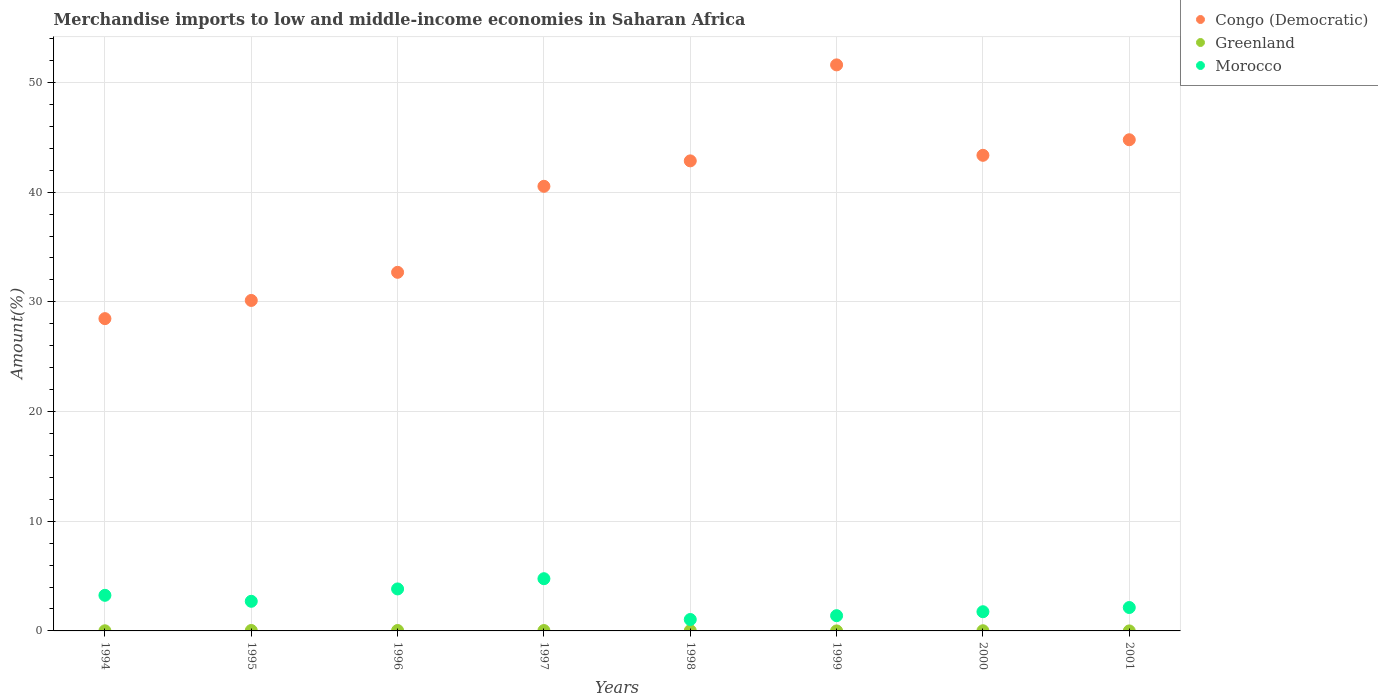How many different coloured dotlines are there?
Offer a terse response. 3. Is the number of dotlines equal to the number of legend labels?
Your answer should be compact. Yes. What is the percentage of amount earned from merchandise imports in Congo (Democratic) in 1996?
Your answer should be compact. 32.69. Across all years, what is the maximum percentage of amount earned from merchandise imports in Morocco?
Offer a very short reply. 4.76. Across all years, what is the minimum percentage of amount earned from merchandise imports in Greenland?
Your response must be concise. 0. What is the total percentage of amount earned from merchandise imports in Morocco in the graph?
Your answer should be very brief. 20.85. What is the difference between the percentage of amount earned from merchandise imports in Morocco in 1996 and that in 1997?
Your response must be concise. -0.93. What is the difference between the percentage of amount earned from merchandise imports in Congo (Democratic) in 1995 and the percentage of amount earned from merchandise imports in Morocco in 2000?
Provide a succinct answer. 28.38. What is the average percentage of amount earned from merchandise imports in Congo (Democratic) per year?
Make the answer very short. 39.3. In the year 1998, what is the difference between the percentage of amount earned from merchandise imports in Greenland and percentage of amount earned from merchandise imports in Congo (Democratic)?
Offer a terse response. -42.83. In how many years, is the percentage of amount earned from merchandise imports in Congo (Democratic) greater than 36 %?
Offer a very short reply. 5. What is the ratio of the percentage of amount earned from merchandise imports in Congo (Democratic) in 1995 to that in 2001?
Your answer should be compact. 0.67. Is the percentage of amount earned from merchandise imports in Morocco in 1998 less than that in 2001?
Provide a short and direct response. Yes. What is the difference between the highest and the second highest percentage of amount earned from merchandise imports in Congo (Democratic)?
Your answer should be compact. 6.83. What is the difference between the highest and the lowest percentage of amount earned from merchandise imports in Congo (Democratic)?
Offer a very short reply. 23.13. Is the sum of the percentage of amount earned from merchandise imports in Greenland in 1998 and 2000 greater than the maximum percentage of amount earned from merchandise imports in Morocco across all years?
Provide a short and direct response. No. Does the percentage of amount earned from merchandise imports in Morocco monotonically increase over the years?
Offer a terse response. No. What is the difference between two consecutive major ticks on the Y-axis?
Your response must be concise. 10. Does the graph contain any zero values?
Your response must be concise. No. Does the graph contain grids?
Offer a very short reply. Yes. What is the title of the graph?
Keep it short and to the point. Merchandise imports to low and middle-income economies in Saharan Africa. Does "Faeroe Islands" appear as one of the legend labels in the graph?
Offer a terse response. No. What is the label or title of the Y-axis?
Your response must be concise. Amount(%). What is the Amount(%) of Congo (Democratic) in 1994?
Make the answer very short. 28.47. What is the Amount(%) in Greenland in 1994?
Provide a short and direct response. 0.01. What is the Amount(%) in Morocco in 1994?
Provide a succinct answer. 3.25. What is the Amount(%) in Congo (Democratic) in 1995?
Keep it short and to the point. 30.13. What is the Amount(%) in Greenland in 1995?
Offer a terse response. 0.04. What is the Amount(%) in Morocco in 1995?
Your response must be concise. 2.7. What is the Amount(%) of Congo (Democratic) in 1996?
Provide a short and direct response. 32.69. What is the Amount(%) of Greenland in 1996?
Give a very brief answer. 0.04. What is the Amount(%) in Morocco in 1996?
Ensure brevity in your answer.  3.83. What is the Amount(%) of Congo (Democratic) in 1997?
Ensure brevity in your answer.  40.53. What is the Amount(%) of Greenland in 1997?
Your answer should be very brief. 0.03. What is the Amount(%) of Morocco in 1997?
Your answer should be compact. 4.76. What is the Amount(%) in Congo (Democratic) in 1998?
Your answer should be compact. 42.85. What is the Amount(%) of Greenland in 1998?
Your answer should be compact. 0.02. What is the Amount(%) in Morocco in 1998?
Provide a succinct answer. 1.04. What is the Amount(%) in Congo (Democratic) in 1999?
Provide a succinct answer. 51.6. What is the Amount(%) of Greenland in 1999?
Offer a terse response. 0. What is the Amount(%) in Morocco in 1999?
Offer a terse response. 1.39. What is the Amount(%) of Congo (Democratic) in 2000?
Make the answer very short. 43.36. What is the Amount(%) in Greenland in 2000?
Keep it short and to the point. 0.02. What is the Amount(%) of Morocco in 2000?
Your answer should be very brief. 1.75. What is the Amount(%) in Congo (Democratic) in 2001?
Ensure brevity in your answer.  44.78. What is the Amount(%) in Greenland in 2001?
Provide a short and direct response. 0. What is the Amount(%) in Morocco in 2001?
Keep it short and to the point. 2.13. Across all years, what is the maximum Amount(%) of Congo (Democratic)?
Make the answer very short. 51.6. Across all years, what is the maximum Amount(%) of Greenland?
Provide a succinct answer. 0.04. Across all years, what is the maximum Amount(%) in Morocco?
Your answer should be very brief. 4.76. Across all years, what is the minimum Amount(%) in Congo (Democratic)?
Ensure brevity in your answer.  28.47. Across all years, what is the minimum Amount(%) of Greenland?
Offer a very short reply. 0. Across all years, what is the minimum Amount(%) of Morocco?
Ensure brevity in your answer.  1.04. What is the total Amount(%) of Congo (Democratic) in the graph?
Offer a terse response. 314.4. What is the total Amount(%) of Greenland in the graph?
Keep it short and to the point. 0.17. What is the total Amount(%) of Morocco in the graph?
Provide a succinct answer. 20.85. What is the difference between the Amount(%) of Congo (Democratic) in 1994 and that in 1995?
Give a very brief answer. -1.66. What is the difference between the Amount(%) in Greenland in 1994 and that in 1995?
Offer a very short reply. -0.03. What is the difference between the Amount(%) in Morocco in 1994 and that in 1995?
Your response must be concise. 0.55. What is the difference between the Amount(%) of Congo (Democratic) in 1994 and that in 1996?
Provide a succinct answer. -4.22. What is the difference between the Amount(%) of Greenland in 1994 and that in 1996?
Provide a short and direct response. -0.03. What is the difference between the Amount(%) in Morocco in 1994 and that in 1996?
Keep it short and to the point. -0.58. What is the difference between the Amount(%) of Congo (Democratic) in 1994 and that in 1997?
Provide a succinct answer. -12.06. What is the difference between the Amount(%) of Greenland in 1994 and that in 1997?
Your answer should be very brief. -0.02. What is the difference between the Amount(%) in Morocco in 1994 and that in 1997?
Give a very brief answer. -1.51. What is the difference between the Amount(%) in Congo (Democratic) in 1994 and that in 1998?
Give a very brief answer. -14.38. What is the difference between the Amount(%) in Greenland in 1994 and that in 1998?
Your answer should be compact. -0.01. What is the difference between the Amount(%) in Morocco in 1994 and that in 1998?
Make the answer very short. 2.2. What is the difference between the Amount(%) in Congo (Democratic) in 1994 and that in 1999?
Make the answer very short. -23.13. What is the difference between the Amount(%) in Greenland in 1994 and that in 1999?
Keep it short and to the point. 0.01. What is the difference between the Amount(%) in Morocco in 1994 and that in 1999?
Give a very brief answer. 1.86. What is the difference between the Amount(%) in Congo (Democratic) in 1994 and that in 2000?
Provide a succinct answer. -14.89. What is the difference between the Amount(%) in Greenland in 1994 and that in 2000?
Offer a terse response. -0. What is the difference between the Amount(%) of Morocco in 1994 and that in 2000?
Offer a very short reply. 1.5. What is the difference between the Amount(%) of Congo (Democratic) in 1994 and that in 2001?
Give a very brief answer. -16.31. What is the difference between the Amount(%) of Greenland in 1994 and that in 2001?
Keep it short and to the point. 0.01. What is the difference between the Amount(%) of Morocco in 1994 and that in 2001?
Your answer should be compact. 1.11. What is the difference between the Amount(%) in Congo (Democratic) in 1995 and that in 1996?
Ensure brevity in your answer.  -2.56. What is the difference between the Amount(%) of Greenland in 1995 and that in 1996?
Offer a very short reply. 0. What is the difference between the Amount(%) in Morocco in 1995 and that in 1996?
Ensure brevity in your answer.  -1.13. What is the difference between the Amount(%) in Congo (Democratic) in 1995 and that in 1997?
Offer a very short reply. -10.4. What is the difference between the Amount(%) of Greenland in 1995 and that in 1997?
Your answer should be very brief. 0.01. What is the difference between the Amount(%) in Morocco in 1995 and that in 1997?
Keep it short and to the point. -2.06. What is the difference between the Amount(%) in Congo (Democratic) in 1995 and that in 1998?
Offer a very short reply. -12.72. What is the difference between the Amount(%) of Greenland in 1995 and that in 1998?
Offer a very short reply. 0.02. What is the difference between the Amount(%) in Morocco in 1995 and that in 1998?
Give a very brief answer. 1.66. What is the difference between the Amount(%) in Congo (Democratic) in 1995 and that in 1999?
Provide a succinct answer. -21.47. What is the difference between the Amount(%) in Greenland in 1995 and that in 1999?
Ensure brevity in your answer.  0.04. What is the difference between the Amount(%) of Morocco in 1995 and that in 1999?
Provide a succinct answer. 1.31. What is the difference between the Amount(%) in Congo (Democratic) in 1995 and that in 2000?
Make the answer very short. -13.23. What is the difference between the Amount(%) of Greenland in 1995 and that in 2000?
Your response must be concise. 0.02. What is the difference between the Amount(%) in Morocco in 1995 and that in 2000?
Your answer should be compact. 0.95. What is the difference between the Amount(%) in Congo (Democratic) in 1995 and that in 2001?
Provide a short and direct response. -14.65. What is the difference between the Amount(%) in Greenland in 1995 and that in 2001?
Your answer should be very brief. 0.04. What is the difference between the Amount(%) in Morocco in 1995 and that in 2001?
Your response must be concise. 0.57. What is the difference between the Amount(%) in Congo (Democratic) in 1996 and that in 1997?
Provide a succinct answer. -7.84. What is the difference between the Amount(%) in Greenland in 1996 and that in 1997?
Make the answer very short. 0.01. What is the difference between the Amount(%) of Morocco in 1996 and that in 1997?
Make the answer very short. -0.93. What is the difference between the Amount(%) in Congo (Democratic) in 1996 and that in 1998?
Keep it short and to the point. -10.16. What is the difference between the Amount(%) of Greenland in 1996 and that in 1998?
Offer a very short reply. 0.02. What is the difference between the Amount(%) in Morocco in 1996 and that in 1998?
Make the answer very short. 2.79. What is the difference between the Amount(%) of Congo (Democratic) in 1996 and that in 1999?
Keep it short and to the point. -18.91. What is the difference between the Amount(%) of Greenland in 1996 and that in 1999?
Give a very brief answer. 0.04. What is the difference between the Amount(%) of Morocco in 1996 and that in 1999?
Offer a terse response. 2.44. What is the difference between the Amount(%) in Congo (Democratic) in 1996 and that in 2000?
Offer a very short reply. -10.67. What is the difference between the Amount(%) of Greenland in 1996 and that in 2000?
Your answer should be compact. 0.02. What is the difference between the Amount(%) in Morocco in 1996 and that in 2000?
Give a very brief answer. 2.08. What is the difference between the Amount(%) of Congo (Democratic) in 1996 and that in 2001?
Offer a terse response. -12.08. What is the difference between the Amount(%) of Greenland in 1996 and that in 2001?
Make the answer very short. 0.04. What is the difference between the Amount(%) of Morocco in 1996 and that in 2001?
Provide a short and direct response. 1.69. What is the difference between the Amount(%) of Congo (Democratic) in 1997 and that in 1998?
Your answer should be very brief. -2.32. What is the difference between the Amount(%) of Greenland in 1997 and that in 1998?
Provide a short and direct response. 0.01. What is the difference between the Amount(%) in Morocco in 1997 and that in 1998?
Provide a short and direct response. 3.72. What is the difference between the Amount(%) in Congo (Democratic) in 1997 and that in 1999?
Ensure brevity in your answer.  -11.07. What is the difference between the Amount(%) in Greenland in 1997 and that in 1999?
Give a very brief answer. 0.03. What is the difference between the Amount(%) in Morocco in 1997 and that in 1999?
Provide a succinct answer. 3.37. What is the difference between the Amount(%) of Congo (Democratic) in 1997 and that in 2000?
Give a very brief answer. -2.83. What is the difference between the Amount(%) in Greenland in 1997 and that in 2000?
Ensure brevity in your answer.  0.02. What is the difference between the Amount(%) in Morocco in 1997 and that in 2000?
Offer a very short reply. 3.01. What is the difference between the Amount(%) of Congo (Democratic) in 1997 and that in 2001?
Provide a short and direct response. -4.24. What is the difference between the Amount(%) of Greenland in 1997 and that in 2001?
Give a very brief answer. 0.03. What is the difference between the Amount(%) of Morocco in 1997 and that in 2001?
Offer a very short reply. 2.63. What is the difference between the Amount(%) in Congo (Democratic) in 1998 and that in 1999?
Provide a succinct answer. -8.75. What is the difference between the Amount(%) of Greenland in 1998 and that in 1999?
Your answer should be very brief. 0.02. What is the difference between the Amount(%) of Morocco in 1998 and that in 1999?
Provide a short and direct response. -0.35. What is the difference between the Amount(%) in Congo (Democratic) in 1998 and that in 2000?
Your answer should be very brief. -0.51. What is the difference between the Amount(%) of Greenland in 1998 and that in 2000?
Make the answer very short. 0.01. What is the difference between the Amount(%) of Morocco in 1998 and that in 2000?
Provide a succinct answer. -0.71. What is the difference between the Amount(%) of Congo (Democratic) in 1998 and that in 2001?
Give a very brief answer. -1.93. What is the difference between the Amount(%) of Greenland in 1998 and that in 2001?
Provide a succinct answer. 0.02. What is the difference between the Amount(%) in Morocco in 1998 and that in 2001?
Keep it short and to the point. -1.09. What is the difference between the Amount(%) of Congo (Democratic) in 1999 and that in 2000?
Make the answer very short. 8.24. What is the difference between the Amount(%) of Greenland in 1999 and that in 2000?
Make the answer very short. -0.02. What is the difference between the Amount(%) in Morocco in 1999 and that in 2000?
Provide a short and direct response. -0.36. What is the difference between the Amount(%) in Congo (Democratic) in 1999 and that in 2001?
Provide a succinct answer. 6.83. What is the difference between the Amount(%) in Greenland in 1999 and that in 2001?
Provide a short and direct response. 0. What is the difference between the Amount(%) in Morocco in 1999 and that in 2001?
Offer a very short reply. -0.74. What is the difference between the Amount(%) in Congo (Democratic) in 2000 and that in 2001?
Provide a succinct answer. -1.42. What is the difference between the Amount(%) in Greenland in 2000 and that in 2001?
Provide a short and direct response. 0.02. What is the difference between the Amount(%) in Morocco in 2000 and that in 2001?
Offer a terse response. -0.38. What is the difference between the Amount(%) in Congo (Democratic) in 1994 and the Amount(%) in Greenland in 1995?
Give a very brief answer. 28.43. What is the difference between the Amount(%) in Congo (Democratic) in 1994 and the Amount(%) in Morocco in 1995?
Make the answer very short. 25.77. What is the difference between the Amount(%) of Greenland in 1994 and the Amount(%) of Morocco in 1995?
Your answer should be very brief. -2.69. What is the difference between the Amount(%) of Congo (Democratic) in 1994 and the Amount(%) of Greenland in 1996?
Offer a terse response. 28.43. What is the difference between the Amount(%) of Congo (Democratic) in 1994 and the Amount(%) of Morocco in 1996?
Keep it short and to the point. 24.64. What is the difference between the Amount(%) of Greenland in 1994 and the Amount(%) of Morocco in 1996?
Provide a succinct answer. -3.82. What is the difference between the Amount(%) in Congo (Democratic) in 1994 and the Amount(%) in Greenland in 1997?
Ensure brevity in your answer.  28.43. What is the difference between the Amount(%) in Congo (Democratic) in 1994 and the Amount(%) in Morocco in 1997?
Your answer should be compact. 23.71. What is the difference between the Amount(%) of Greenland in 1994 and the Amount(%) of Morocco in 1997?
Provide a short and direct response. -4.75. What is the difference between the Amount(%) of Congo (Democratic) in 1994 and the Amount(%) of Greenland in 1998?
Your answer should be compact. 28.44. What is the difference between the Amount(%) of Congo (Democratic) in 1994 and the Amount(%) of Morocco in 1998?
Your response must be concise. 27.43. What is the difference between the Amount(%) in Greenland in 1994 and the Amount(%) in Morocco in 1998?
Provide a short and direct response. -1.03. What is the difference between the Amount(%) of Congo (Democratic) in 1994 and the Amount(%) of Greenland in 1999?
Make the answer very short. 28.47. What is the difference between the Amount(%) in Congo (Democratic) in 1994 and the Amount(%) in Morocco in 1999?
Make the answer very short. 27.08. What is the difference between the Amount(%) of Greenland in 1994 and the Amount(%) of Morocco in 1999?
Make the answer very short. -1.38. What is the difference between the Amount(%) in Congo (Democratic) in 1994 and the Amount(%) in Greenland in 2000?
Your response must be concise. 28.45. What is the difference between the Amount(%) in Congo (Democratic) in 1994 and the Amount(%) in Morocco in 2000?
Offer a terse response. 26.72. What is the difference between the Amount(%) in Greenland in 1994 and the Amount(%) in Morocco in 2000?
Provide a short and direct response. -1.74. What is the difference between the Amount(%) of Congo (Democratic) in 1994 and the Amount(%) of Greenland in 2001?
Your answer should be compact. 28.47. What is the difference between the Amount(%) of Congo (Democratic) in 1994 and the Amount(%) of Morocco in 2001?
Your answer should be very brief. 26.33. What is the difference between the Amount(%) of Greenland in 1994 and the Amount(%) of Morocco in 2001?
Keep it short and to the point. -2.12. What is the difference between the Amount(%) in Congo (Democratic) in 1995 and the Amount(%) in Greenland in 1996?
Provide a short and direct response. 30.09. What is the difference between the Amount(%) of Congo (Democratic) in 1995 and the Amount(%) of Morocco in 1996?
Your response must be concise. 26.3. What is the difference between the Amount(%) of Greenland in 1995 and the Amount(%) of Morocco in 1996?
Offer a very short reply. -3.79. What is the difference between the Amount(%) of Congo (Democratic) in 1995 and the Amount(%) of Greenland in 1997?
Offer a terse response. 30.09. What is the difference between the Amount(%) of Congo (Democratic) in 1995 and the Amount(%) of Morocco in 1997?
Your answer should be very brief. 25.37. What is the difference between the Amount(%) of Greenland in 1995 and the Amount(%) of Morocco in 1997?
Give a very brief answer. -4.72. What is the difference between the Amount(%) in Congo (Democratic) in 1995 and the Amount(%) in Greenland in 1998?
Make the answer very short. 30.1. What is the difference between the Amount(%) of Congo (Democratic) in 1995 and the Amount(%) of Morocco in 1998?
Offer a very short reply. 29.09. What is the difference between the Amount(%) of Greenland in 1995 and the Amount(%) of Morocco in 1998?
Offer a very short reply. -1. What is the difference between the Amount(%) of Congo (Democratic) in 1995 and the Amount(%) of Greenland in 1999?
Provide a succinct answer. 30.13. What is the difference between the Amount(%) of Congo (Democratic) in 1995 and the Amount(%) of Morocco in 1999?
Your answer should be very brief. 28.74. What is the difference between the Amount(%) in Greenland in 1995 and the Amount(%) in Morocco in 1999?
Provide a short and direct response. -1.35. What is the difference between the Amount(%) in Congo (Democratic) in 1995 and the Amount(%) in Greenland in 2000?
Provide a short and direct response. 30.11. What is the difference between the Amount(%) of Congo (Democratic) in 1995 and the Amount(%) of Morocco in 2000?
Make the answer very short. 28.38. What is the difference between the Amount(%) in Greenland in 1995 and the Amount(%) in Morocco in 2000?
Give a very brief answer. -1.71. What is the difference between the Amount(%) in Congo (Democratic) in 1995 and the Amount(%) in Greenland in 2001?
Provide a succinct answer. 30.13. What is the difference between the Amount(%) of Congo (Democratic) in 1995 and the Amount(%) of Morocco in 2001?
Provide a succinct answer. 27.99. What is the difference between the Amount(%) in Greenland in 1995 and the Amount(%) in Morocco in 2001?
Your answer should be very brief. -2.09. What is the difference between the Amount(%) of Congo (Democratic) in 1996 and the Amount(%) of Greenland in 1997?
Provide a short and direct response. 32.66. What is the difference between the Amount(%) in Congo (Democratic) in 1996 and the Amount(%) in Morocco in 1997?
Provide a short and direct response. 27.93. What is the difference between the Amount(%) of Greenland in 1996 and the Amount(%) of Morocco in 1997?
Keep it short and to the point. -4.72. What is the difference between the Amount(%) of Congo (Democratic) in 1996 and the Amount(%) of Greenland in 1998?
Offer a very short reply. 32.67. What is the difference between the Amount(%) in Congo (Democratic) in 1996 and the Amount(%) in Morocco in 1998?
Offer a very short reply. 31.65. What is the difference between the Amount(%) in Greenland in 1996 and the Amount(%) in Morocco in 1998?
Provide a short and direct response. -1. What is the difference between the Amount(%) of Congo (Democratic) in 1996 and the Amount(%) of Greenland in 1999?
Your response must be concise. 32.69. What is the difference between the Amount(%) in Congo (Democratic) in 1996 and the Amount(%) in Morocco in 1999?
Keep it short and to the point. 31.3. What is the difference between the Amount(%) of Greenland in 1996 and the Amount(%) of Morocco in 1999?
Provide a short and direct response. -1.35. What is the difference between the Amount(%) in Congo (Democratic) in 1996 and the Amount(%) in Greenland in 2000?
Your answer should be compact. 32.67. What is the difference between the Amount(%) of Congo (Democratic) in 1996 and the Amount(%) of Morocco in 2000?
Provide a succinct answer. 30.94. What is the difference between the Amount(%) in Greenland in 1996 and the Amount(%) in Morocco in 2000?
Give a very brief answer. -1.71. What is the difference between the Amount(%) in Congo (Democratic) in 1996 and the Amount(%) in Greenland in 2001?
Your response must be concise. 32.69. What is the difference between the Amount(%) of Congo (Democratic) in 1996 and the Amount(%) of Morocco in 2001?
Your answer should be very brief. 30.56. What is the difference between the Amount(%) in Greenland in 1996 and the Amount(%) in Morocco in 2001?
Ensure brevity in your answer.  -2.09. What is the difference between the Amount(%) in Congo (Democratic) in 1997 and the Amount(%) in Greenland in 1998?
Provide a succinct answer. 40.51. What is the difference between the Amount(%) of Congo (Democratic) in 1997 and the Amount(%) of Morocco in 1998?
Your answer should be very brief. 39.49. What is the difference between the Amount(%) of Greenland in 1997 and the Amount(%) of Morocco in 1998?
Ensure brevity in your answer.  -1.01. What is the difference between the Amount(%) in Congo (Democratic) in 1997 and the Amount(%) in Greenland in 1999?
Provide a succinct answer. 40.53. What is the difference between the Amount(%) in Congo (Democratic) in 1997 and the Amount(%) in Morocco in 1999?
Keep it short and to the point. 39.14. What is the difference between the Amount(%) in Greenland in 1997 and the Amount(%) in Morocco in 1999?
Provide a succinct answer. -1.36. What is the difference between the Amount(%) of Congo (Democratic) in 1997 and the Amount(%) of Greenland in 2000?
Offer a terse response. 40.51. What is the difference between the Amount(%) in Congo (Democratic) in 1997 and the Amount(%) in Morocco in 2000?
Offer a terse response. 38.78. What is the difference between the Amount(%) of Greenland in 1997 and the Amount(%) of Morocco in 2000?
Make the answer very short. -1.72. What is the difference between the Amount(%) in Congo (Democratic) in 1997 and the Amount(%) in Greenland in 2001?
Make the answer very short. 40.53. What is the difference between the Amount(%) in Congo (Democratic) in 1997 and the Amount(%) in Morocco in 2001?
Provide a succinct answer. 38.4. What is the difference between the Amount(%) of Greenland in 1997 and the Amount(%) of Morocco in 2001?
Provide a short and direct response. -2.1. What is the difference between the Amount(%) of Congo (Democratic) in 1998 and the Amount(%) of Greenland in 1999?
Your answer should be compact. 42.85. What is the difference between the Amount(%) of Congo (Democratic) in 1998 and the Amount(%) of Morocco in 1999?
Ensure brevity in your answer.  41.46. What is the difference between the Amount(%) in Greenland in 1998 and the Amount(%) in Morocco in 1999?
Ensure brevity in your answer.  -1.37. What is the difference between the Amount(%) in Congo (Democratic) in 1998 and the Amount(%) in Greenland in 2000?
Provide a succinct answer. 42.83. What is the difference between the Amount(%) in Congo (Democratic) in 1998 and the Amount(%) in Morocco in 2000?
Offer a terse response. 41.1. What is the difference between the Amount(%) in Greenland in 1998 and the Amount(%) in Morocco in 2000?
Provide a short and direct response. -1.73. What is the difference between the Amount(%) of Congo (Democratic) in 1998 and the Amount(%) of Greenland in 2001?
Ensure brevity in your answer.  42.85. What is the difference between the Amount(%) in Congo (Democratic) in 1998 and the Amount(%) in Morocco in 2001?
Provide a short and direct response. 40.72. What is the difference between the Amount(%) in Greenland in 1998 and the Amount(%) in Morocco in 2001?
Make the answer very short. -2.11. What is the difference between the Amount(%) of Congo (Democratic) in 1999 and the Amount(%) of Greenland in 2000?
Give a very brief answer. 51.58. What is the difference between the Amount(%) of Congo (Democratic) in 1999 and the Amount(%) of Morocco in 2000?
Provide a succinct answer. 49.85. What is the difference between the Amount(%) of Greenland in 1999 and the Amount(%) of Morocco in 2000?
Keep it short and to the point. -1.75. What is the difference between the Amount(%) of Congo (Democratic) in 1999 and the Amount(%) of Greenland in 2001?
Provide a short and direct response. 51.6. What is the difference between the Amount(%) of Congo (Democratic) in 1999 and the Amount(%) of Morocco in 2001?
Give a very brief answer. 49.47. What is the difference between the Amount(%) of Greenland in 1999 and the Amount(%) of Morocco in 2001?
Give a very brief answer. -2.13. What is the difference between the Amount(%) in Congo (Democratic) in 2000 and the Amount(%) in Greenland in 2001?
Ensure brevity in your answer.  43.36. What is the difference between the Amount(%) of Congo (Democratic) in 2000 and the Amount(%) of Morocco in 2001?
Your response must be concise. 41.22. What is the difference between the Amount(%) of Greenland in 2000 and the Amount(%) of Morocco in 2001?
Your answer should be compact. -2.12. What is the average Amount(%) of Congo (Democratic) per year?
Ensure brevity in your answer.  39.3. What is the average Amount(%) of Greenland per year?
Provide a short and direct response. 0.02. What is the average Amount(%) of Morocco per year?
Provide a short and direct response. 2.61. In the year 1994, what is the difference between the Amount(%) in Congo (Democratic) and Amount(%) in Greenland?
Provide a short and direct response. 28.46. In the year 1994, what is the difference between the Amount(%) of Congo (Democratic) and Amount(%) of Morocco?
Your answer should be compact. 25.22. In the year 1994, what is the difference between the Amount(%) of Greenland and Amount(%) of Morocco?
Your response must be concise. -3.23. In the year 1995, what is the difference between the Amount(%) of Congo (Democratic) and Amount(%) of Greenland?
Make the answer very short. 30.09. In the year 1995, what is the difference between the Amount(%) in Congo (Democratic) and Amount(%) in Morocco?
Your answer should be compact. 27.43. In the year 1995, what is the difference between the Amount(%) of Greenland and Amount(%) of Morocco?
Make the answer very short. -2.66. In the year 1996, what is the difference between the Amount(%) of Congo (Democratic) and Amount(%) of Greenland?
Your answer should be compact. 32.65. In the year 1996, what is the difference between the Amount(%) in Congo (Democratic) and Amount(%) in Morocco?
Keep it short and to the point. 28.86. In the year 1996, what is the difference between the Amount(%) of Greenland and Amount(%) of Morocco?
Give a very brief answer. -3.79. In the year 1997, what is the difference between the Amount(%) in Congo (Democratic) and Amount(%) in Greenland?
Offer a very short reply. 40.5. In the year 1997, what is the difference between the Amount(%) of Congo (Democratic) and Amount(%) of Morocco?
Offer a terse response. 35.77. In the year 1997, what is the difference between the Amount(%) of Greenland and Amount(%) of Morocco?
Give a very brief answer. -4.73. In the year 1998, what is the difference between the Amount(%) in Congo (Democratic) and Amount(%) in Greenland?
Provide a short and direct response. 42.83. In the year 1998, what is the difference between the Amount(%) in Congo (Democratic) and Amount(%) in Morocco?
Your response must be concise. 41.81. In the year 1998, what is the difference between the Amount(%) in Greenland and Amount(%) in Morocco?
Offer a terse response. -1.02. In the year 1999, what is the difference between the Amount(%) in Congo (Democratic) and Amount(%) in Greenland?
Offer a terse response. 51.6. In the year 1999, what is the difference between the Amount(%) of Congo (Democratic) and Amount(%) of Morocco?
Your answer should be very brief. 50.21. In the year 1999, what is the difference between the Amount(%) in Greenland and Amount(%) in Morocco?
Provide a succinct answer. -1.39. In the year 2000, what is the difference between the Amount(%) of Congo (Democratic) and Amount(%) of Greenland?
Keep it short and to the point. 43.34. In the year 2000, what is the difference between the Amount(%) in Congo (Democratic) and Amount(%) in Morocco?
Ensure brevity in your answer.  41.61. In the year 2000, what is the difference between the Amount(%) of Greenland and Amount(%) of Morocco?
Keep it short and to the point. -1.73. In the year 2001, what is the difference between the Amount(%) in Congo (Democratic) and Amount(%) in Greenland?
Your answer should be very brief. 44.77. In the year 2001, what is the difference between the Amount(%) of Congo (Democratic) and Amount(%) of Morocco?
Offer a very short reply. 42.64. In the year 2001, what is the difference between the Amount(%) of Greenland and Amount(%) of Morocco?
Your answer should be compact. -2.13. What is the ratio of the Amount(%) in Congo (Democratic) in 1994 to that in 1995?
Give a very brief answer. 0.94. What is the ratio of the Amount(%) of Greenland in 1994 to that in 1995?
Your response must be concise. 0.31. What is the ratio of the Amount(%) of Morocco in 1994 to that in 1995?
Ensure brevity in your answer.  1.2. What is the ratio of the Amount(%) in Congo (Democratic) in 1994 to that in 1996?
Your answer should be very brief. 0.87. What is the ratio of the Amount(%) of Greenland in 1994 to that in 1996?
Provide a short and direct response. 0.31. What is the ratio of the Amount(%) of Morocco in 1994 to that in 1996?
Provide a short and direct response. 0.85. What is the ratio of the Amount(%) of Congo (Democratic) in 1994 to that in 1997?
Your answer should be compact. 0.7. What is the ratio of the Amount(%) in Greenland in 1994 to that in 1997?
Provide a succinct answer. 0.36. What is the ratio of the Amount(%) of Morocco in 1994 to that in 1997?
Your answer should be very brief. 0.68. What is the ratio of the Amount(%) in Congo (Democratic) in 1994 to that in 1998?
Your response must be concise. 0.66. What is the ratio of the Amount(%) of Greenland in 1994 to that in 1998?
Keep it short and to the point. 0.52. What is the ratio of the Amount(%) of Morocco in 1994 to that in 1998?
Provide a short and direct response. 3.12. What is the ratio of the Amount(%) in Congo (Democratic) in 1994 to that in 1999?
Your answer should be compact. 0.55. What is the ratio of the Amount(%) in Greenland in 1994 to that in 1999?
Your answer should be very brief. 9.49. What is the ratio of the Amount(%) of Morocco in 1994 to that in 1999?
Your answer should be very brief. 2.34. What is the ratio of the Amount(%) in Congo (Democratic) in 1994 to that in 2000?
Make the answer very short. 0.66. What is the ratio of the Amount(%) in Greenland in 1994 to that in 2000?
Offer a very short reply. 0.74. What is the ratio of the Amount(%) of Morocco in 1994 to that in 2000?
Your response must be concise. 1.85. What is the ratio of the Amount(%) in Congo (Democratic) in 1994 to that in 2001?
Ensure brevity in your answer.  0.64. What is the ratio of the Amount(%) in Greenland in 1994 to that in 2001?
Offer a very short reply. 21.29. What is the ratio of the Amount(%) in Morocco in 1994 to that in 2001?
Provide a succinct answer. 1.52. What is the ratio of the Amount(%) in Congo (Democratic) in 1995 to that in 1996?
Your response must be concise. 0.92. What is the ratio of the Amount(%) in Greenland in 1995 to that in 1996?
Give a very brief answer. 1.02. What is the ratio of the Amount(%) of Morocco in 1995 to that in 1996?
Keep it short and to the point. 0.71. What is the ratio of the Amount(%) of Congo (Democratic) in 1995 to that in 1997?
Your response must be concise. 0.74. What is the ratio of the Amount(%) of Greenland in 1995 to that in 1997?
Your answer should be very brief. 1.17. What is the ratio of the Amount(%) of Morocco in 1995 to that in 1997?
Your answer should be very brief. 0.57. What is the ratio of the Amount(%) in Congo (Democratic) in 1995 to that in 1998?
Keep it short and to the point. 0.7. What is the ratio of the Amount(%) in Greenland in 1995 to that in 1998?
Give a very brief answer. 1.68. What is the ratio of the Amount(%) in Morocco in 1995 to that in 1998?
Your answer should be very brief. 2.59. What is the ratio of the Amount(%) in Congo (Democratic) in 1995 to that in 1999?
Provide a succinct answer. 0.58. What is the ratio of the Amount(%) in Greenland in 1995 to that in 1999?
Provide a short and direct response. 30.94. What is the ratio of the Amount(%) in Morocco in 1995 to that in 1999?
Make the answer very short. 1.94. What is the ratio of the Amount(%) of Congo (Democratic) in 1995 to that in 2000?
Provide a succinct answer. 0.69. What is the ratio of the Amount(%) in Greenland in 1995 to that in 2000?
Your answer should be very brief. 2.42. What is the ratio of the Amount(%) of Morocco in 1995 to that in 2000?
Your response must be concise. 1.54. What is the ratio of the Amount(%) in Congo (Democratic) in 1995 to that in 2001?
Keep it short and to the point. 0.67. What is the ratio of the Amount(%) of Greenland in 1995 to that in 2001?
Offer a terse response. 69.41. What is the ratio of the Amount(%) of Morocco in 1995 to that in 2001?
Provide a short and direct response. 1.27. What is the ratio of the Amount(%) in Congo (Democratic) in 1996 to that in 1997?
Make the answer very short. 0.81. What is the ratio of the Amount(%) in Greenland in 1996 to that in 1997?
Make the answer very short. 1.15. What is the ratio of the Amount(%) of Morocco in 1996 to that in 1997?
Your response must be concise. 0.8. What is the ratio of the Amount(%) in Congo (Democratic) in 1996 to that in 1998?
Make the answer very short. 0.76. What is the ratio of the Amount(%) in Greenland in 1996 to that in 1998?
Give a very brief answer. 1.66. What is the ratio of the Amount(%) of Morocco in 1996 to that in 1998?
Your answer should be compact. 3.68. What is the ratio of the Amount(%) in Congo (Democratic) in 1996 to that in 1999?
Ensure brevity in your answer.  0.63. What is the ratio of the Amount(%) of Greenland in 1996 to that in 1999?
Your response must be concise. 30.46. What is the ratio of the Amount(%) of Morocco in 1996 to that in 1999?
Your answer should be very brief. 2.75. What is the ratio of the Amount(%) in Congo (Democratic) in 1996 to that in 2000?
Provide a succinct answer. 0.75. What is the ratio of the Amount(%) in Greenland in 1996 to that in 2000?
Keep it short and to the point. 2.38. What is the ratio of the Amount(%) in Morocco in 1996 to that in 2000?
Provide a short and direct response. 2.19. What is the ratio of the Amount(%) in Congo (Democratic) in 1996 to that in 2001?
Offer a terse response. 0.73. What is the ratio of the Amount(%) in Greenland in 1996 to that in 2001?
Keep it short and to the point. 68.32. What is the ratio of the Amount(%) in Morocco in 1996 to that in 2001?
Your answer should be very brief. 1.79. What is the ratio of the Amount(%) of Congo (Democratic) in 1997 to that in 1998?
Offer a terse response. 0.95. What is the ratio of the Amount(%) of Greenland in 1997 to that in 1998?
Your response must be concise. 1.44. What is the ratio of the Amount(%) of Morocco in 1997 to that in 1998?
Your response must be concise. 4.57. What is the ratio of the Amount(%) of Congo (Democratic) in 1997 to that in 1999?
Your answer should be compact. 0.79. What is the ratio of the Amount(%) in Greenland in 1997 to that in 1999?
Your answer should be very brief. 26.51. What is the ratio of the Amount(%) in Morocco in 1997 to that in 1999?
Offer a terse response. 3.43. What is the ratio of the Amount(%) in Congo (Democratic) in 1997 to that in 2000?
Offer a very short reply. 0.93. What is the ratio of the Amount(%) of Greenland in 1997 to that in 2000?
Offer a terse response. 2.07. What is the ratio of the Amount(%) in Morocco in 1997 to that in 2000?
Ensure brevity in your answer.  2.72. What is the ratio of the Amount(%) in Congo (Democratic) in 1997 to that in 2001?
Ensure brevity in your answer.  0.91. What is the ratio of the Amount(%) in Greenland in 1997 to that in 2001?
Keep it short and to the point. 59.47. What is the ratio of the Amount(%) of Morocco in 1997 to that in 2001?
Make the answer very short. 2.23. What is the ratio of the Amount(%) in Congo (Democratic) in 1998 to that in 1999?
Give a very brief answer. 0.83. What is the ratio of the Amount(%) of Greenland in 1998 to that in 1999?
Your response must be concise. 18.4. What is the ratio of the Amount(%) of Morocco in 1998 to that in 1999?
Offer a terse response. 0.75. What is the ratio of the Amount(%) of Congo (Democratic) in 1998 to that in 2000?
Provide a succinct answer. 0.99. What is the ratio of the Amount(%) of Greenland in 1998 to that in 2000?
Offer a very short reply. 1.44. What is the ratio of the Amount(%) of Morocco in 1998 to that in 2000?
Make the answer very short. 0.6. What is the ratio of the Amount(%) in Greenland in 1998 to that in 2001?
Your answer should be very brief. 41.27. What is the ratio of the Amount(%) in Morocco in 1998 to that in 2001?
Your answer should be compact. 0.49. What is the ratio of the Amount(%) of Congo (Democratic) in 1999 to that in 2000?
Provide a succinct answer. 1.19. What is the ratio of the Amount(%) of Greenland in 1999 to that in 2000?
Offer a very short reply. 0.08. What is the ratio of the Amount(%) in Morocco in 1999 to that in 2000?
Keep it short and to the point. 0.79. What is the ratio of the Amount(%) of Congo (Democratic) in 1999 to that in 2001?
Give a very brief answer. 1.15. What is the ratio of the Amount(%) in Greenland in 1999 to that in 2001?
Your answer should be very brief. 2.24. What is the ratio of the Amount(%) of Morocco in 1999 to that in 2001?
Make the answer very short. 0.65. What is the ratio of the Amount(%) of Congo (Democratic) in 2000 to that in 2001?
Offer a very short reply. 0.97. What is the ratio of the Amount(%) of Greenland in 2000 to that in 2001?
Offer a very short reply. 28.71. What is the ratio of the Amount(%) in Morocco in 2000 to that in 2001?
Provide a short and direct response. 0.82. What is the difference between the highest and the second highest Amount(%) in Congo (Democratic)?
Offer a very short reply. 6.83. What is the difference between the highest and the second highest Amount(%) in Greenland?
Provide a short and direct response. 0. What is the difference between the highest and the second highest Amount(%) in Morocco?
Give a very brief answer. 0.93. What is the difference between the highest and the lowest Amount(%) in Congo (Democratic)?
Give a very brief answer. 23.13. What is the difference between the highest and the lowest Amount(%) in Greenland?
Keep it short and to the point. 0.04. What is the difference between the highest and the lowest Amount(%) in Morocco?
Make the answer very short. 3.72. 